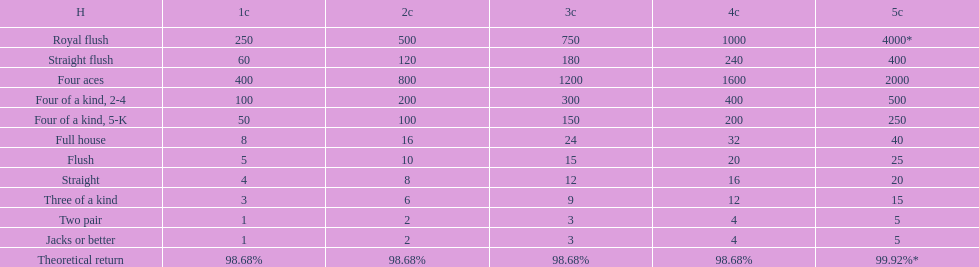At most, what could a person earn for having a full house? 40. 